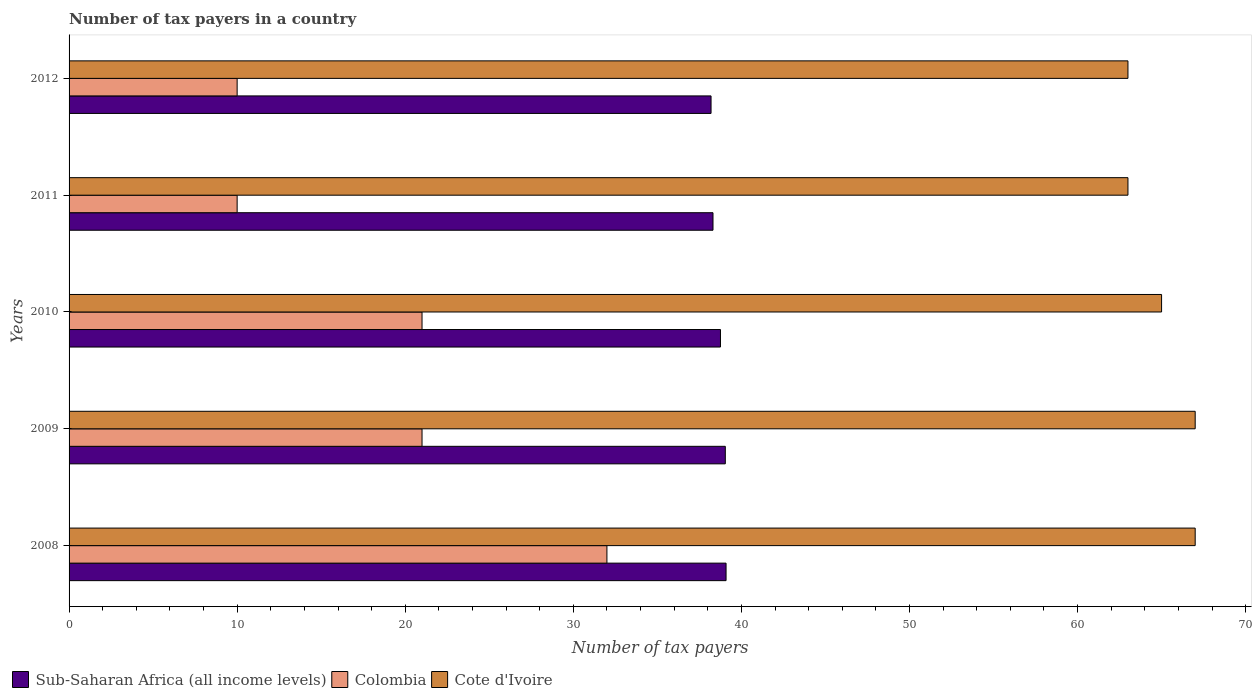How many groups of bars are there?
Provide a short and direct response. 5. Are the number of bars per tick equal to the number of legend labels?
Provide a succinct answer. Yes. Are the number of bars on each tick of the Y-axis equal?
Offer a very short reply. Yes. How many bars are there on the 1st tick from the bottom?
Your answer should be compact. 3. In how many cases, is the number of bars for a given year not equal to the number of legend labels?
Give a very brief answer. 0. What is the number of tax payers in in Colombia in 2012?
Provide a succinct answer. 10. Across all years, what is the maximum number of tax payers in in Colombia?
Provide a succinct answer. 32. Across all years, what is the minimum number of tax payers in in Sub-Saharan Africa (all income levels)?
Your response must be concise. 38.2. In which year was the number of tax payers in in Sub-Saharan Africa (all income levels) maximum?
Your answer should be compact. 2008. What is the total number of tax payers in in Sub-Saharan Africa (all income levels) in the graph?
Your answer should be very brief. 193.4. What is the difference between the number of tax payers in in Cote d'Ivoire in 2008 and that in 2011?
Offer a very short reply. 4. What is the difference between the number of tax payers in in Sub-Saharan Africa (all income levels) in 2009 and the number of tax payers in in Cote d'Ivoire in 2008?
Offer a terse response. -27.96. What is the average number of tax payers in in Cote d'Ivoire per year?
Your answer should be very brief. 65. In the year 2012, what is the difference between the number of tax payers in in Sub-Saharan Africa (all income levels) and number of tax payers in in Colombia?
Offer a terse response. 28.2. What is the ratio of the number of tax payers in in Sub-Saharan Africa (all income levels) in 2011 to that in 2012?
Give a very brief answer. 1. Is the number of tax payers in in Sub-Saharan Africa (all income levels) in 2008 less than that in 2011?
Offer a very short reply. No. Is the difference between the number of tax payers in in Sub-Saharan Africa (all income levels) in 2008 and 2011 greater than the difference between the number of tax payers in in Colombia in 2008 and 2011?
Ensure brevity in your answer.  No. What is the difference between the highest and the second highest number of tax payers in in Sub-Saharan Africa (all income levels)?
Ensure brevity in your answer.  0.04. What is the difference between the highest and the lowest number of tax payers in in Colombia?
Offer a very short reply. 22. What does the 1st bar from the top in 2012 represents?
Your answer should be very brief. Cote d'Ivoire. What does the 1st bar from the bottom in 2011 represents?
Make the answer very short. Sub-Saharan Africa (all income levels). Is it the case that in every year, the sum of the number of tax payers in in Cote d'Ivoire and number of tax payers in in Sub-Saharan Africa (all income levels) is greater than the number of tax payers in in Colombia?
Your response must be concise. Yes. How many years are there in the graph?
Your answer should be very brief. 5. What is the difference between two consecutive major ticks on the X-axis?
Make the answer very short. 10. Are the values on the major ticks of X-axis written in scientific E-notation?
Give a very brief answer. No. Does the graph contain any zero values?
Your answer should be compact. No. Where does the legend appear in the graph?
Provide a short and direct response. Bottom left. How many legend labels are there?
Your answer should be compact. 3. What is the title of the graph?
Your response must be concise. Number of tax payers in a country. What is the label or title of the X-axis?
Make the answer very short. Number of tax payers. What is the Number of tax payers of Sub-Saharan Africa (all income levels) in 2008?
Your response must be concise. 39.09. What is the Number of tax payers in Colombia in 2008?
Provide a short and direct response. 32. What is the Number of tax payers in Cote d'Ivoire in 2008?
Your answer should be compact. 67. What is the Number of tax payers of Sub-Saharan Africa (all income levels) in 2009?
Provide a short and direct response. 39.04. What is the Number of tax payers of Colombia in 2009?
Keep it short and to the point. 21. What is the Number of tax payers of Cote d'Ivoire in 2009?
Provide a short and direct response. 67. What is the Number of tax payers in Sub-Saharan Africa (all income levels) in 2010?
Provide a short and direct response. 38.76. What is the Number of tax payers of Cote d'Ivoire in 2010?
Your answer should be very brief. 65. What is the Number of tax payers in Sub-Saharan Africa (all income levels) in 2011?
Give a very brief answer. 38.31. What is the Number of tax payers in Colombia in 2011?
Provide a short and direct response. 10. What is the Number of tax payers of Sub-Saharan Africa (all income levels) in 2012?
Keep it short and to the point. 38.2. What is the Number of tax payers of Colombia in 2012?
Provide a short and direct response. 10. What is the Number of tax payers of Cote d'Ivoire in 2012?
Your answer should be compact. 63. Across all years, what is the maximum Number of tax payers of Sub-Saharan Africa (all income levels)?
Offer a very short reply. 39.09. Across all years, what is the maximum Number of tax payers of Cote d'Ivoire?
Make the answer very short. 67. Across all years, what is the minimum Number of tax payers of Sub-Saharan Africa (all income levels)?
Provide a short and direct response. 38.2. What is the total Number of tax payers in Sub-Saharan Africa (all income levels) in the graph?
Give a very brief answer. 193.4. What is the total Number of tax payers in Colombia in the graph?
Keep it short and to the point. 94. What is the total Number of tax payers in Cote d'Ivoire in the graph?
Offer a very short reply. 325. What is the difference between the Number of tax payers of Sub-Saharan Africa (all income levels) in 2008 and that in 2009?
Offer a terse response. 0.04. What is the difference between the Number of tax payers in Colombia in 2008 and that in 2009?
Offer a very short reply. 11. What is the difference between the Number of tax payers of Cote d'Ivoire in 2008 and that in 2009?
Provide a short and direct response. 0. What is the difference between the Number of tax payers of Sub-Saharan Africa (all income levels) in 2008 and that in 2010?
Your answer should be compact. 0.33. What is the difference between the Number of tax payers of Colombia in 2008 and that in 2011?
Ensure brevity in your answer.  22. What is the difference between the Number of tax payers in Cote d'Ivoire in 2008 and that in 2011?
Provide a short and direct response. 4. What is the difference between the Number of tax payers in Sub-Saharan Africa (all income levels) in 2008 and that in 2012?
Your answer should be compact. 0.89. What is the difference between the Number of tax payers in Colombia in 2008 and that in 2012?
Provide a short and direct response. 22. What is the difference between the Number of tax payers of Cote d'Ivoire in 2008 and that in 2012?
Your response must be concise. 4. What is the difference between the Number of tax payers of Sub-Saharan Africa (all income levels) in 2009 and that in 2010?
Your answer should be compact. 0.29. What is the difference between the Number of tax payers of Colombia in 2009 and that in 2010?
Offer a very short reply. 0. What is the difference between the Number of tax payers of Sub-Saharan Africa (all income levels) in 2009 and that in 2011?
Your response must be concise. 0.73. What is the difference between the Number of tax payers in Sub-Saharan Africa (all income levels) in 2009 and that in 2012?
Give a very brief answer. 0.85. What is the difference between the Number of tax payers of Colombia in 2009 and that in 2012?
Keep it short and to the point. 11. What is the difference between the Number of tax payers of Sub-Saharan Africa (all income levels) in 2010 and that in 2011?
Your answer should be very brief. 0.44. What is the difference between the Number of tax payers in Colombia in 2010 and that in 2011?
Ensure brevity in your answer.  11. What is the difference between the Number of tax payers in Sub-Saharan Africa (all income levels) in 2010 and that in 2012?
Your answer should be very brief. 0.56. What is the difference between the Number of tax payers in Sub-Saharan Africa (all income levels) in 2011 and that in 2012?
Offer a terse response. 0.12. What is the difference between the Number of tax payers of Colombia in 2011 and that in 2012?
Ensure brevity in your answer.  0. What is the difference between the Number of tax payers in Cote d'Ivoire in 2011 and that in 2012?
Give a very brief answer. 0. What is the difference between the Number of tax payers of Sub-Saharan Africa (all income levels) in 2008 and the Number of tax payers of Colombia in 2009?
Your response must be concise. 18.09. What is the difference between the Number of tax payers in Sub-Saharan Africa (all income levels) in 2008 and the Number of tax payers in Cote d'Ivoire in 2009?
Your response must be concise. -27.91. What is the difference between the Number of tax payers of Colombia in 2008 and the Number of tax payers of Cote d'Ivoire in 2009?
Give a very brief answer. -35. What is the difference between the Number of tax payers of Sub-Saharan Africa (all income levels) in 2008 and the Number of tax payers of Colombia in 2010?
Give a very brief answer. 18.09. What is the difference between the Number of tax payers of Sub-Saharan Africa (all income levels) in 2008 and the Number of tax payers of Cote d'Ivoire in 2010?
Your answer should be very brief. -25.91. What is the difference between the Number of tax payers of Colombia in 2008 and the Number of tax payers of Cote d'Ivoire in 2010?
Keep it short and to the point. -33. What is the difference between the Number of tax payers in Sub-Saharan Africa (all income levels) in 2008 and the Number of tax payers in Colombia in 2011?
Provide a short and direct response. 29.09. What is the difference between the Number of tax payers in Sub-Saharan Africa (all income levels) in 2008 and the Number of tax payers in Cote d'Ivoire in 2011?
Provide a short and direct response. -23.91. What is the difference between the Number of tax payers of Colombia in 2008 and the Number of tax payers of Cote d'Ivoire in 2011?
Your response must be concise. -31. What is the difference between the Number of tax payers of Sub-Saharan Africa (all income levels) in 2008 and the Number of tax payers of Colombia in 2012?
Offer a terse response. 29.09. What is the difference between the Number of tax payers of Sub-Saharan Africa (all income levels) in 2008 and the Number of tax payers of Cote d'Ivoire in 2012?
Your response must be concise. -23.91. What is the difference between the Number of tax payers of Colombia in 2008 and the Number of tax payers of Cote d'Ivoire in 2012?
Ensure brevity in your answer.  -31. What is the difference between the Number of tax payers of Sub-Saharan Africa (all income levels) in 2009 and the Number of tax payers of Colombia in 2010?
Provide a short and direct response. 18.04. What is the difference between the Number of tax payers in Sub-Saharan Africa (all income levels) in 2009 and the Number of tax payers in Cote d'Ivoire in 2010?
Make the answer very short. -25.96. What is the difference between the Number of tax payers in Colombia in 2009 and the Number of tax payers in Cote d'Ivoire in 2010?
Provide a succinct answer. -44. What is the difference between the Number of tax payers in Sub-Saharan Africa (all income levels) in 2009 and the Number of tax payers in Colombia in 2011?
Make the answer very short. 29.04. What is the difference between the Number of tax payers of Sub-Saharan Africa (all income levels) in 2009 and the Number of tax payers of Cote d'Ivoire in 2011?
Your response must be concise. -23.96. What is the difference between the Number of tax payers in Colombia in 2009 and the Number of tax payers in Cote d'Ivoire in 2011?
Your answer should be compact. -42. What is the difference between the Number of tax payers of Sub-Saharan Africa (all income levels) in 2009 and the Number of tax payers of Colombia in 2012?
Make the answer very short. 29.04. What is the difference between the Number of tax payers in Sub-Saharan Africa (all income levels) in 2009 and the Number of tax payers in Cote d'Ivoire in 2012?
Offer a very short reply. -23.96. What is the difference between the Number of tax payers of Colombia in 2009 and the Number of tax payers of Cote d'Ivoire in 2012?
Provide a short and direct response. -42. What is the difference between the Number of tax payers in Sub-Saharan Africa (all income levels) in 2010 and the Number of tax payers in Colombia in 2011?
Provide a short and direct response. 28.76. What is the difference between the Number of tax payers in Sub-Saharan Africa (all income levels) in 2010 and the Number of tax payers in Cote d'Ivoire in 2011?
Offer a very short reply. -24.24. What is the difference between the Number of tax payers in Colombia in 2010 and the Number of tax payers in Cote d'Ivoire in 2011?
Give a very brief answer. -42. What is the difference between the Number of tax payers of Sub-Saharan Africa (all income levels) in 2010 and the Number of tax payers of Colombia in 2012?
Make the answer very short. 28.76. What is the difference between the Number of tax payers of Sub-Saharan Africa (all income levels) in 2010 and the Number of tax payers of Cote d'Ivoire in 2012?
Keep it short and to the point. -24.24. What is the difference between the Number of tax payers in Colombia in 2010 and the Number of tax payers in Cote d'Ivoire in 2012?
Your answer should be very brief. -42. What is the difference between the Number of tax payers of Sub-Saharan Africa (all income levels) in 2011 and the Number of tax payers of Colombia in 2012?
Make the answer very short. 28.31. What is the difference between the Number of tax payers of Sub-Saharan Africa (all income levels) in 2011 and the Number of tax payers of Cote d'Ivoire in 2012?
Provide a succinct answer. -24.69. What is the difference between the Number of tax payers of Colombia in 2011 and the Number of tax payers of Cote d'Ivoire in 2012?
Keep it short and to the point. -53. What is the average Number of tax payers in Sub-Saharan Africa (all income levels) per year?
Provide a succinct answer. 38.68. What is the average Number of tax payers of Colombia per year?
Your answer should be very brief. 18.8. In the year 2008, what is the difference between the Number of tax payers of Sub-Saharan Africa (all income levels) and Number of tax payers of Colombia?
Make the answer very short. 7.09. In the year 2008, what is the difference between the Number of tax payers in Sub-Saharan Africa (all income levels) and Number of tax payers in Cote d'Ivoire?
Provide a short and direct response. -27.91. In the year 2008, what is the difference between the Number of tax payers of Colombia and Number of tax payers of Cote d'Ivoire?
Ensure brevity in your answer.  -35. In the year 2009, what is the difference between the Number of tax payers in Sub-Saharan Africa (all income levels) and Number of tax payers in Colombia?
Offer a very short reply. 18.04. In the year 2009, what is the difference between the Number of tax payers in Sub-Saharan Africa (all income levels) and Number of tax payers in Cote d'Ivoire?
Your answer should be compact. -27.96. In the year 2009, what is the difference between the Number of tax payers in Colombia and Number of tax payers in Cote d'Ivoire?
Offer a very short reply. -46. In the year 2010, what is the difference between the Number of tax payers of Sub-Saharan Africa (all income levels) and Number of tax payers of Colombia?
Offer a terse response. 17.76. In the year 2010, what is the difference between the Number of tax payers of Sub-Saharan Africa (all income levels) and Number of tax payers of Cote d'Ivoire?
Offer a terse response. -26.24. In the year 2010, what is the difference between the Number of tax payers in Colombia and Number of tax payers in Cote d'Ivoire?
Your answer should be very brief. -44. In the year 2011, what is the difference between the Number of tax payers in Sub-Saharan Africa (all income levels) and Number of tax payers in Colombia?
Offer a terse response. 28.31. In the year 2011, what is the difference between the Number of tax payers in Sub-Saharan Africa (all income levels) and Number of tax payers in Cote d'Ivoire?
Your answer should be compact. -24.69. In the year 2011, what is the difference between the Number of tax payers of Colombia and Number of tax payers of Cote d'Ivoire?
Your answer should be compact. -53. In the year 2012, what is the difference between the Number of tax payers in Sub-Saharan Africa (all income levels) and Number of tax payers in Colombia?
Give a very brief answer. 28.2. In the year 2012, what is the difference between the Number of tax payers of Sub-Saharan Africa (all income levels) and Number of tax payers of Cote d'Ivoire?
Offer a very short reply. -24.8. In the year 2012, what is the difference between the Number of tax payers of Colombia and Number of tax payers of Cote d'Ivoire?
Ensure brevity in your answer.  -53. What is the ratio of the Number of tax payers in Colombia in 2008 to that in 2009?
Offer a terse response. 1.52. What is the ratio of the Number of tax payers in Sub-Saharan Africa (all income levels) in 2008 to that in 2010?
Keep it short and to the point. 1.01. What is the ratio of the Number of tax payers of Colombia in 2008 to that in 2010?
Your answer should be compact. 1.52. What is the ratio of the Number of tax payers of Cote d'Ivoire in 2008 to that in 2010?
Keep it short and to the point. 1.03. What is the ratio of the Number of tax payers of Sub-Saharan Africa (all income levels) in 2008 to that in 2011?
Your answer should be very brief. 1.02. What is the ratio of the Number of tax payers in Colombia in 2008 to that in 2011?
Make the answer very short. 3.2. What is the ratio of the Number of tax payers in Cote d'Ivoire in 2008 to that in 2011?
Ensure brevity in your answer.  1.06. What is the ratio of the Number of tax payers in Sub-Saharan Africa (all income levels) in 2008 to that in 2012?
Make the answer very short. 1.02. What is the ratio of the Number of tax payers in Colombia in 2008 to that in 2012?
Your answer should be very brief. 3.2. What is the ratio of the Number of tax payers of Cote d'Ivoire in 2008 to that in 2012?
Offer a very short reply. 1.06. What is the ratio of the Number of tax payers of Sub-Saharan Africa (all income levels) in 2009 to that in 2010?
Provide a short and direct response. 1.01. What is the ratio of the Number of tax payers of Colombia in 2009 to that in 2010?
Your response must be concise. 1. What is the ratio of the Number of tax payers of Cote d'Ivoire in 2009 to that in 2010?
Your answer should be very brief. 1.03. What is the ratio of the Number of tax payers of Sub-Saharan Africa (all income levels) in 2009 to that in 2011?
Offer a very short reply. 1.02. What is the ratio of the Number of tax payers of Cote d'Ivoire in 2009 to that in 2011?
Offer a very short reply. 1.06. What is the ratio of the Number of tax payers in Sub-Saharan Africa (all income levels) in 2009 to that in 2012?
Give a very brief answer. 1.02. What is the ratio of the Number of tax payers in Colombia in 2009 to that in 2012?
Make the answer very short. 2.1. What is the ratio of the Number of tax payers in Cote d'Ivoire in 2009 to that in 2012?
Your response must be concise. 1.06. What is the ratio of the Number of tax payers of Sub-Saharan Africa (all income levels) in 2010 to that in 2011?
Make the answer very short. 1.01. What is the ratio of the Number of tax payers of Cote d'Ivoire in 2010 to that in 2011?
Offer a very short reply. 1.03. What is the ratio of the Number of tax payers in Sub-Saharan Africa (all income levels) in 2010 to that in 2012?
Your answer should be very brief. 1.01. What is the ratio of the Number of tax payers of Cote d'Ivoire in 2010 to that in 2012?
Your response must be concise. 1.03. What is the ratio of the Number of tax payers in Sub-Saharan Africa (all income levels) in 2011 to that in 2012?
Offer a very short reply. 1. What is the difference between the highest and the second highest Number of tax payers in Sub-Saharan Africa (all income levels)?
Keep it short and to the point. 0.04. What is the difference between the highest and the lowest Number of tax payers in Sub-Saharan Africa (all income levels)?
Provide a short and direct response. 0.89. 